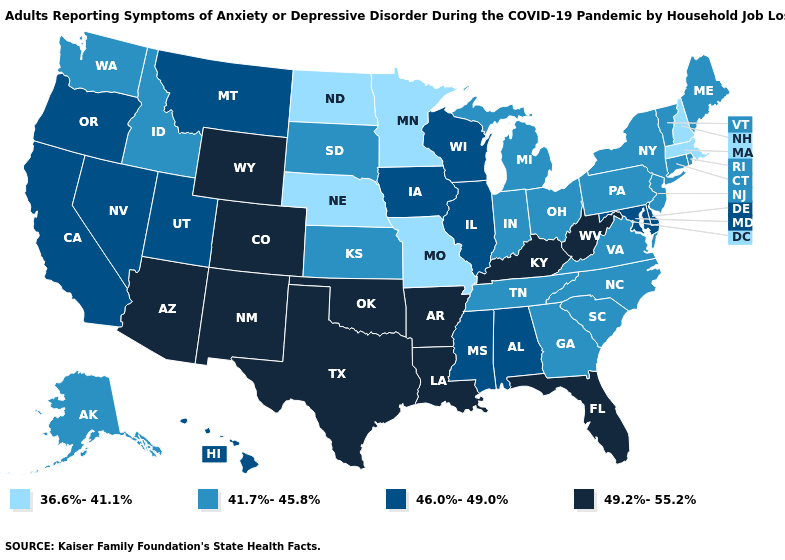Is the legend a continuous bar?
Answer briefly. No. Does Idaho have the highest value in the West?
Write a very short answer. No. Name the states that have a value in the range 41.7%-45.8%?
Keep it brief. Alaska, Connecticut, Georgia, Idaho, Indiana, Kansas, Maine, Michigan, New Jersey, New York, North Carolina, Ohio, Pennsylvania, Rhode Island, South Carolina, South Dakota, Tennessee, Vermont, Virginia, Washington. Does Maryland have the same value as Montana?
Quick response, please. Yes. Is the legend a continuous bar?
Give a very brief answer. No. What is the value of Indiana?
Write a very short answer. 41.7%-45.8%. Among the states that border Colorado , does Wyoming have the lowest value?
Keep it brief. No. Name the states that have a value in the range 49.2%-55.2%?
Short answer required. Arizona, Arkansas, Colorado, Florida, Kentucky, Louisiana, New Mexico, Oklahoma, Texas, West Virginia, Wyoming. What is the value of Ohio?
Keep it brief. 41.7%-45.8%. Name the states that have a value in the range 49.2%-55.2%?
Short answer required. Arizona, Arkansas, Colorado, Florida, Kentucky, Louisiana, New Mexico, Oklahoma, Texas, West Virginia, Wyoming. Among the states that border Oregon , does Washington have the lowest value?
Keep it brief. Yes. What is the value of Virginia?
Concise answer only. 41.7%-45.8%. What is the value of West Virginia?
Give a very brief answer. 49.2%-55.2%. Does Oregon have a lower value than Texas?
Short answer required. Yes. 